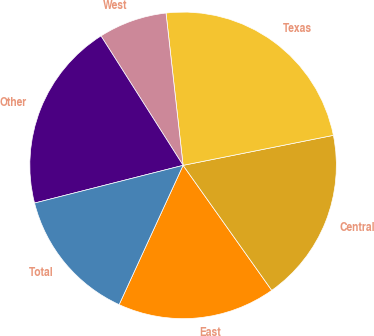Convert chart. <chart><loc_0><loc_0><loc_500><loc_500><pie_chart><fcel>East<fcel>Central<fcel>Texas<fcel>West<fcel>Other<fcel>Total<nl><fcel>16.67%<fcel>18.32%<fcel>23.64%<fcel>7.22%<fcel>19.96%<fcel>14.19%<nl></chart> 